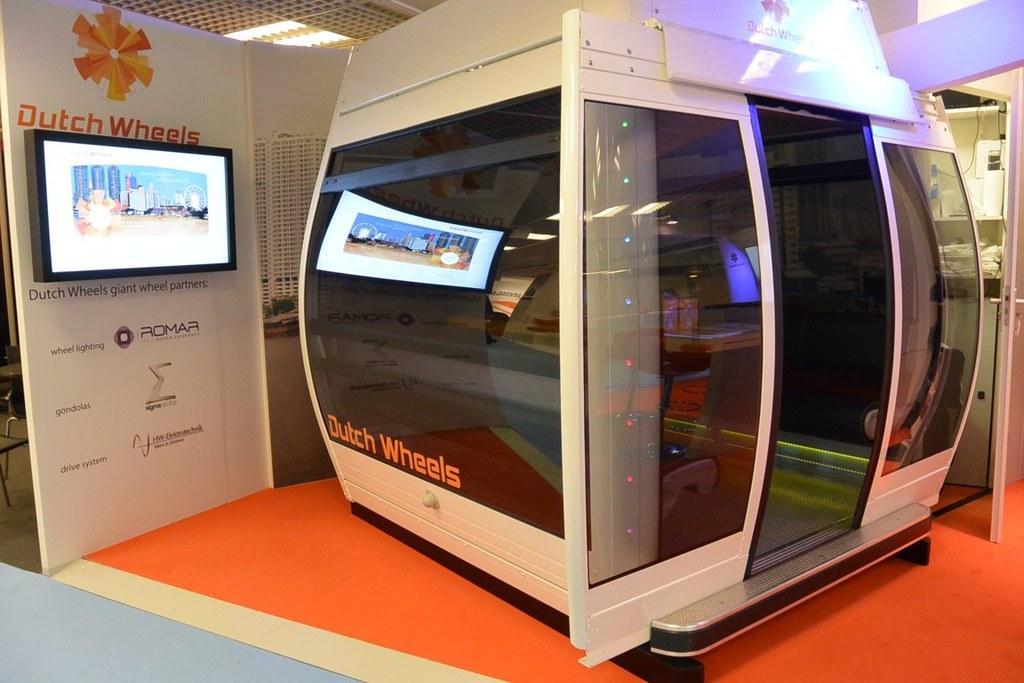Describe this image in one or two sentences. It is a machine, there are glasses for this. On the left side there is a t. v. 